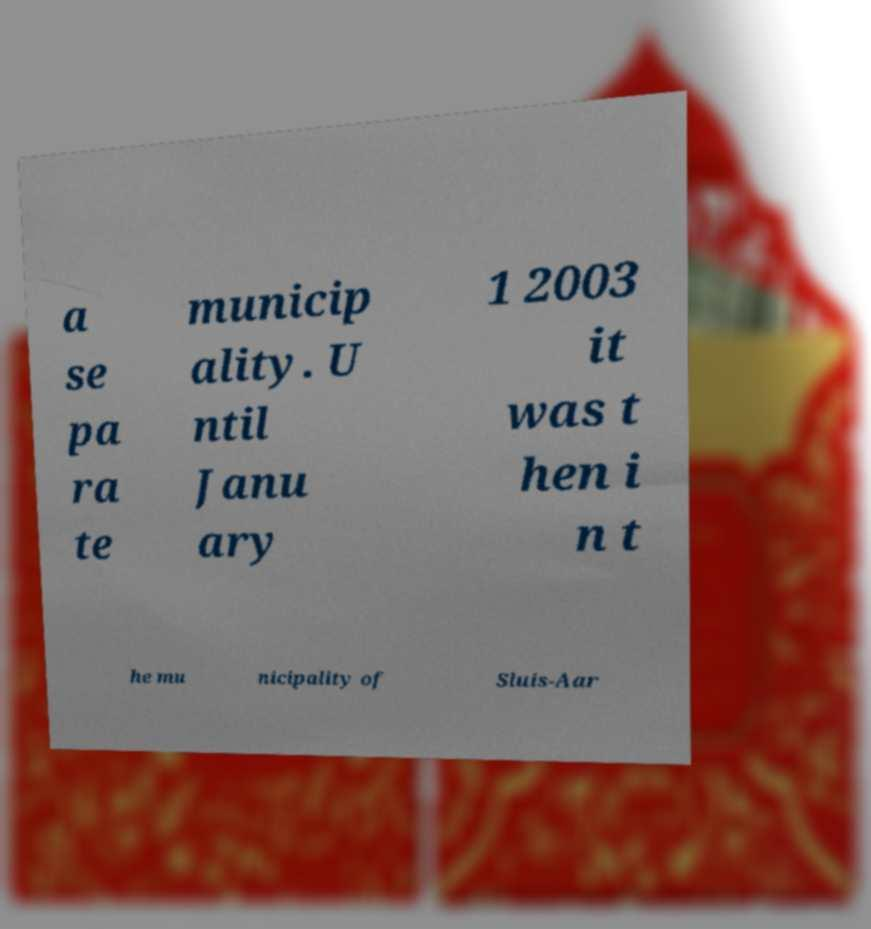Could you extract and type out the text from this image? a se pa ra te municip ality. U ntil Janu ary 1 2003 it was t hen i n t he mu nicipality of Sluis-Aar 